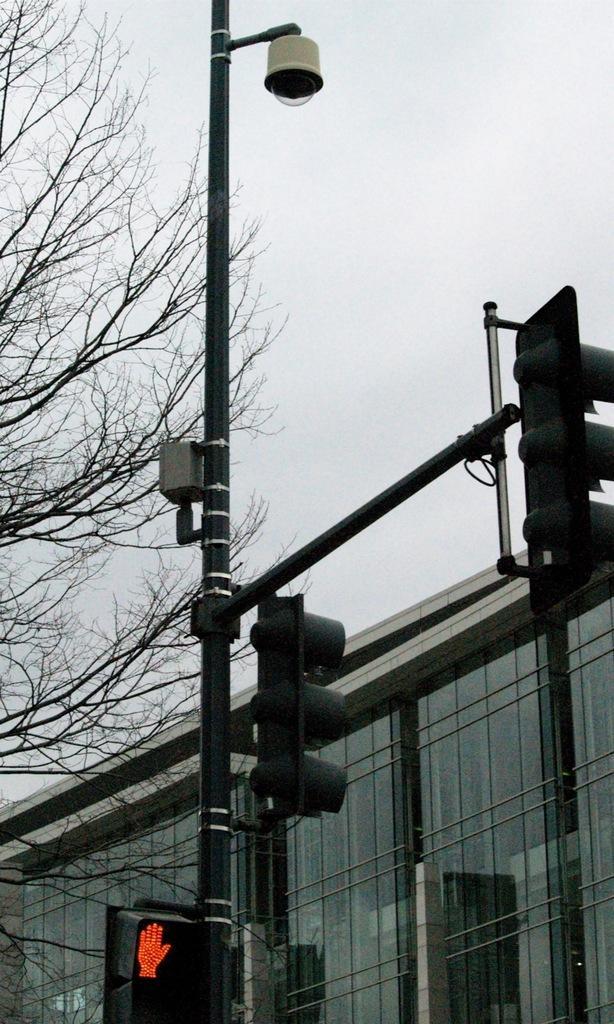Could you give a brief overview of what you see in this image? In this image, we can see a poles with traffic signals and CCTV camera. Background we can see a glass building, tree and sky. 